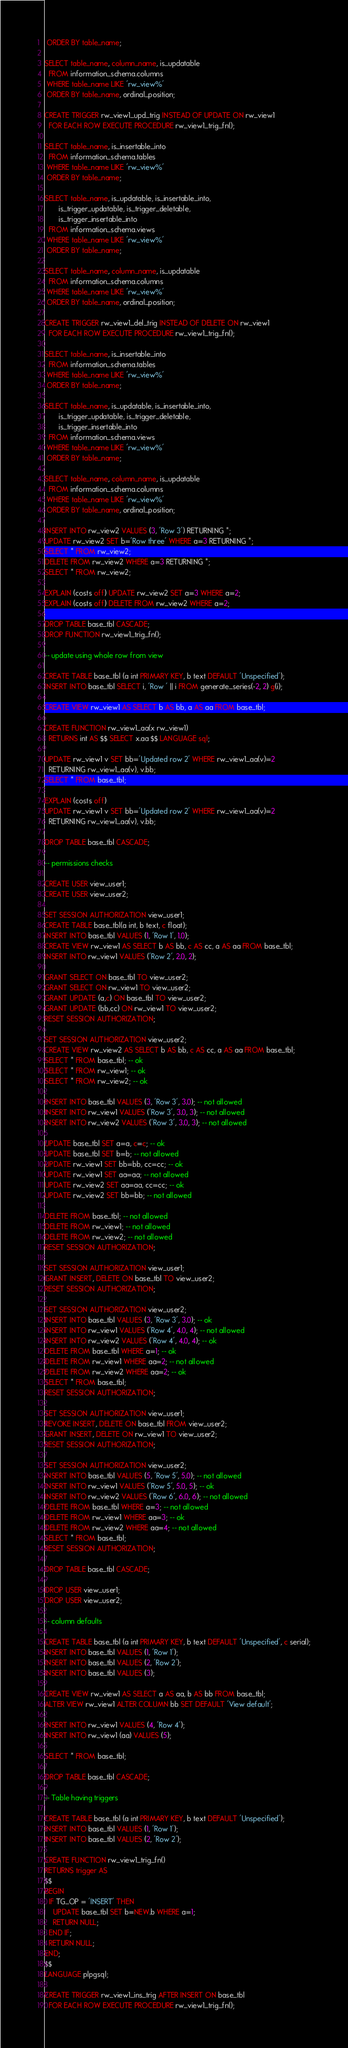Convert code to text. <code><loc_0><loc_0><loc_500><loc_500><_SQL_> ORDER BY table_name;

SELECT table_name, column_name, is_updatable
  FROM information_schema.columns
 WHERE table_name LIKE 'rw_view%'
 ORDER BY table_name, ordinal_position;

CREATE TRIGGER rw_view1_upd_trig INSTEAD OF UPDATE ON rw_view1
  FOR EACH ROW EXECUTE PROCEDURE rw_view1_trig_fn();

SELECT table_name, is_insertable_into
  FROM information_schema.tables
 WHERE table_name LIKE 'rw_view%'
 ORDER BY table_name;

SELECT table_name, is_updatable, is_insertable_into,
       is_trigger_updatable, is_trigger_deletable,
       is_trigger_insertable_into
  FROM information_schema.views
 WHERE table_name LIKE 'rw_view%'
 ORDER BY table_name;

SELECT table_name, column_name, is_updatable
  FROM information_schema.columns
 WHERE table_name LIKE 'rw_view%'
 ORDER BY table_name, ordinal_position;

CREATE TRIGGER rw_view1_del_trig INSTEAD OF DELETE ON rw_view1
  FOR EACH ROW EXECUTE PROCEDURE rw_view1_trig_fn();

SELECT table_name, is_insertable_into
  FROM information_schema.tables
 WHERE table_name LIKE 'rw_view%'
 ORDER BY table_name;

SELECT table_name, is_updatable, is_insertable_into,
       is_trigger_updatable, is_trigger_deletable,
       is_trigger_insertable_into
  FROM information_schema.views
 WHERE table_name LIKE 'rw_view%'
 ORDER BY table_name;

SELECT table_name, column_name, is_updatable
  FROM information_schema.columns
 WHERE table_name LIKE 'rw_view%'
 ORDER BY table_name, ordinal_position;

INSERT INTO rw_view2 VALUES (3, 'Row 3') RETURNING *;
UPDATE rw_view2 SET b='Row three' WHERE a=3 RETURNING *;
SELECT * FROM rw_view2;
DELETE FROM rw_view2 WHERE a=3 RETURNING *;
SELECT * FROM rw_view2;

EXPLAIN (costs off) UPDATE rw_view2 SET a=3 WHERE a=2;
EXPLAIN (costs off) DELETE FROM rw_view2 WHERE a=2;

DROP TABLE base_tbl CASCADE;
DROP FUNCTION rw_view1_trig_fn();

-- update using whole row from view

CREATE TABLE base_tbl (a int PRIMARY KEY, b text DEFAULT 'Unspecified');
INSERT INTO base_tbl SELECT i, 'Row ' || i FROM generate_series(-2, 2) g(i);

CREATE VIEW rw_view1 AS SELECT b AS bb, a AS aa FROM base_tbl;

CREATE FUNCTION rw_view1_aa(x rw_view1)
  RETURNS int AS $$ SELECT x.aa $$ LANGUAGE sql;

UPDATE rw_view1 v SET bb='Updated row 2' WHERE rw_view1_aa(v)=2
  RETURNING rw_view1_aa(v), v.bb;
SELECT * FROM base_tbl;

EXPLAIN (costs off)
UPDATE rw_view1 v SET bb='Updated row 2' WHERE rw_view1_aa(v)=2
  RETURNING rw_view1_aa(v), v.bb;

DROP TABLE base_tbl CASCADE;

-- permissions checks

CREATE USER view_user1;
CREATE USER view_user2;

SET SESSION AUTHORIZATION view_user1;
CREATE TABLE base_tbl(a int, b text, c float);
INSERT INTO base_tbl VALUES (1, 'Row 1', 1.0);
CREATE VIEW rw_view1 AS SELECT b AS bb, c AS cc, a AS aa FROM base_tbl;
INSERT INTO rw_view1 VALUES ('Row 2', 2.0, 2);

GRANT SELECT ON base_tbl TO view_user2;
GRANT SELECT ON rw_view1 TO view_user2;
GRANT UPDATE (a,c) ON base_tbl TO view_user2;
GRANT UPDATE (bb,cc) ON rw_view1 TO view_user2;
RESET SESSION AUTHORIZATION;

SET SESSION AUTHORIZATION view_user2;
CREATE VIEW rw_view2 AS SELECT b AS bb, c AS cc, a AS aa FROM base_tbl;
SELECT * FROM base_tbl; -- ok
SELECT * FROM rw_view1; -- ok
SELECT * FROM rw_view2; -- ok

INSERT INTO base_tbl VALUES (3, 'Row 3', 3.0); -- not allowed
INSERT INTO rw_view1 VALUES ('Row 3', 3.0, 3); -- not allowed
INSERT INTO rw_view2 VALUES ('Row 3', 3.0, 3); -- not allowed

UPDATE base_tbl SET a=a, c=c; -- ok
UPDATE base_tbl SET b=b; -- not allowed
UPDATE rw_view1 SET bb=bb, cc=cc; -- ok
UPDATE rw_view1 SET aa=aa; -- not allowed
UPDATE rw_view2 SET aa=aa, cc=cc; -- ok
UPDATE rw_view2 SET bb=bb; -- not allowed

DELETE FROM base_tbl; -- not allowed
DELETE FROM rw_view1; -- not allowed
DELETE FROM rw_view2; -- not allowed
RESET SESSION AUTHORIZATION;

SET SESSION AUTHORIZATION view_user1;
GRANT INSERT, DELETE ON base_tbl TO view_user2;
RESET SESSION AUTHORIZATION;

SET SESSION AUTHORIZATION view_user2;
INSERT INTO base_tbl VALUES (3, 'Row 3', 3.0); -- ok
INSERT INTO rw_view1 VALUES ('Row 4', 4.0, 4); -- not allowed
INSERT INTO rw_view2 VALUES ('Row 4', 4.0, 4); -- ok
DELETE FROM base_tbl WHERE a=1; -- ok
DELETE FROM rw_view1 WHERE aa=2; -- not allowed
DELETE FROM rw_view2 WHERE aa=2; -- ok
SELECT * FROM base_tbl;
RESET SESSION AUTHORIZATION;

SET SESSION AUTHORIZATION view_user1;
REVOKE INSERT, DELETE ON base_tbl FROM view_user2;
GRANT INSERT, DELETE ON rw_view1 TO view_user2;
RESET SESSION AUTHORIZATION;

SET SESSION AUTHORIZATION view_user2;
INSERT INTO base_tbl VALUES (5, 'Row 5', 5.0); -- not allowed
INSERT INTO rw_view1 VALUES ('Row 5', 5.0, 5); -- ok
INSERT INTO rw_view2 VALUES ('Row 6', 6.0, 6); -- not allowed
DELETE FROM base_tbl WHERE a=3; -- not allowed
DELETE FROM rw_view1 WHERE aa=3; -- ok
DELETE FROM rw_view2 WHERE aa=4; -- not allowed
SELECT * FROM base_tbl;
RESET SESSION AUTHORIZATION;

DROP TABLE base_tbl CASCADE;

DROP USER view_user1;
DROP USER view_user2;

-- column defaults

CREATE TABLE base_tbl (a int PRIMARY KEY, b text DEFAULT 'Unspecified', c serial);
INSERT INTO base_tbl VALUES (1, 'Row 1');
INSERT INTO base_tbl VALUES (2, 'Row 2');
INSERT INTO base_tbl VALUES (3);

CREATE VIEW rw_view1 AS SELECT a AS aa, b AS bb FROM base_tbl;
ALTER VIEW rw_view1 ALTER COLUMN bb SET DEFAULT 'View default';

INSERT INTO rw_view1 VALUES (4, 'Row 4');
INSERT INTO rw_view1 (aa) VALUES (5);

SELECT * FROM base_tbl;

DROP TABLE base_tbl CASCADE;

-- Table having triggers

CREATE TABLE base_tbl (a int PRIMARY KEY, b text DEFAULT 'Unspecified');
INSERT INTO base_tbl VALUES (1, 'Row 1');
INSERT INTO base_tbl VALUES (2, 'Row 2');

CREATE FUNCTION rw_view1_trig_fn()
RETURNS trigger AS
$$
BEGIN
  IF TG_OP = 'INSERT' THEN
    UPDATE base_tbl SET b=NEW.b WHERE a=1;
    RETURN NULL;
  END IF;
  RETURN NULL;
END;
$$
LANGUAGE plpgsql;

CREATE TRIGGER rw_view1_ins_trig AFTER INSERT ON base_tbl
  FOR EACH ROW EXECUTE PROCEDURE rw_view1_trig_fn();
</code> 